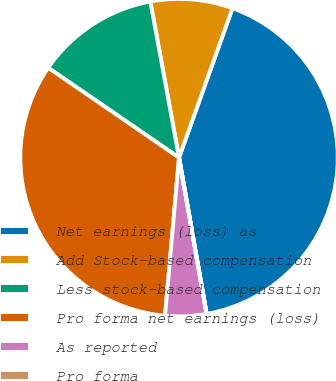<chart> <loc_0><loc_0><loc_500><loc_500><pie_chart><fcel>Net earnings (loss) as<fcel>Add Stock-based compensation<fcel>Less stock-based compensation<fcel>Pro forma net earnings (loss)<fcel>As reported<fcel>Pro forma<nl><fcel>41.74%<fcel>8.36%<fcel>12.53%<fcel>33.17%<fcel>4.18%<fcel>0.01%<nl></chart> 